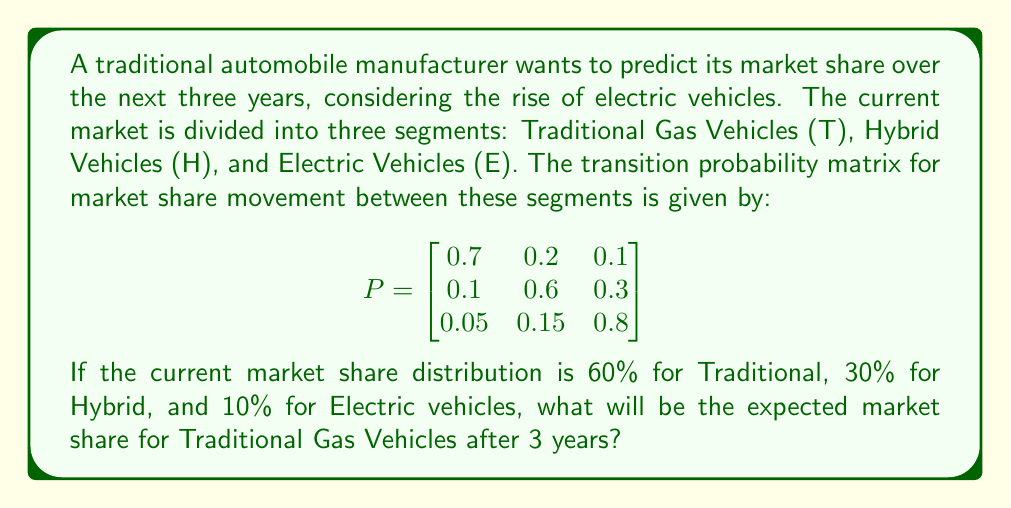Give your solution to this math problem. To solve this problem, we'll use the Markov chain model and matrix multiplication. Let's approach this step-by-step:

1) First, we need to represent the initial market share as a row vector:
   
   $$X_0 = \begin{bmatrix} 0.6 & 0.3 & 0.1 \end{bmatrix}$$

2) The formula to calculate the market share after n steps is:
   
   $$X_n = X_0 \cdot P^n$$

   Where $P^n$ is the transition matrix raised to the power of n.

3) We need to calculate $P^3$ (as we're looking 3 years ahead):
   
   $$P^2 = P \cdot P = \begin{bmatrix}
   0.505 & 0.270 & 0.225 \\
   0.175 & 0.435 & 0.390 \\
   0.0875 & 0.2025 & 0.7100
   \end{bmatrix}$$

   $$P^3 = P^2 \cdot P = \begin{bmatrix}
   0.38675 & 0.29175 & 0.32150 \\
   0.22625 & 0.32625 & 0.44750 \\
   0.11938 & 0.23063 & 0.65000
   \end{bmatrix}$$

4) Now, we can calculate $X_3$:
   
   $$X_3 = X_0 \cdot P^3 = \begin{bmatrix} 0.6 & 0.3 & 0.1 \end{bmatrix} \cdot \begin{bmatrix}
   0.38675 & 0.29175 & 0.32150 \\
   0.22625 & 0.32625 & 0.44750 \\
   0.11938 & 0.23063 & 0.65000
   \end{bmatrix}$$

5) Performing the matrix multiplication:
   
   $$X_3 = \begin{bmatrix} 0.32429 & 0.29944 & 0.37627 \end{bmatrix}$$

6) The first element of this vector represents the market share for Traditional Gas Vehicles after 3 years.

Therefore, the expected market share for Traditional Gas Vehicles after 3 years is approximately 0.32429 or 32.429%.
Answer: 32.429% 